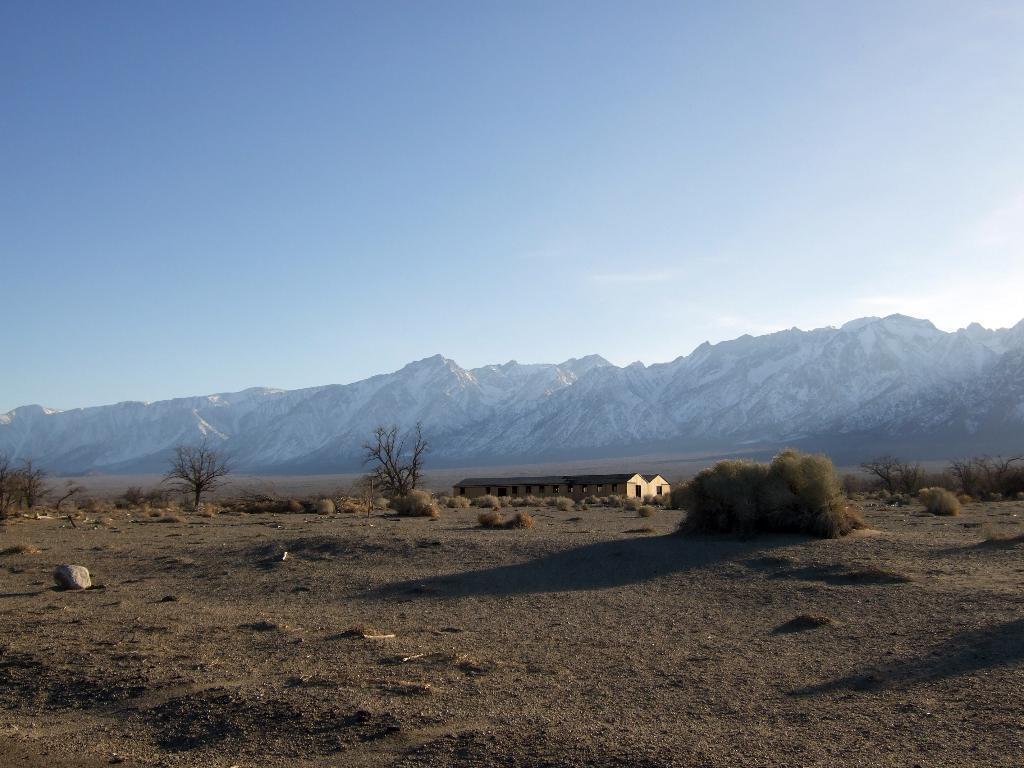Describe this image in one or two sentences. In this picture I can see some houses, trees and I can see open land. 